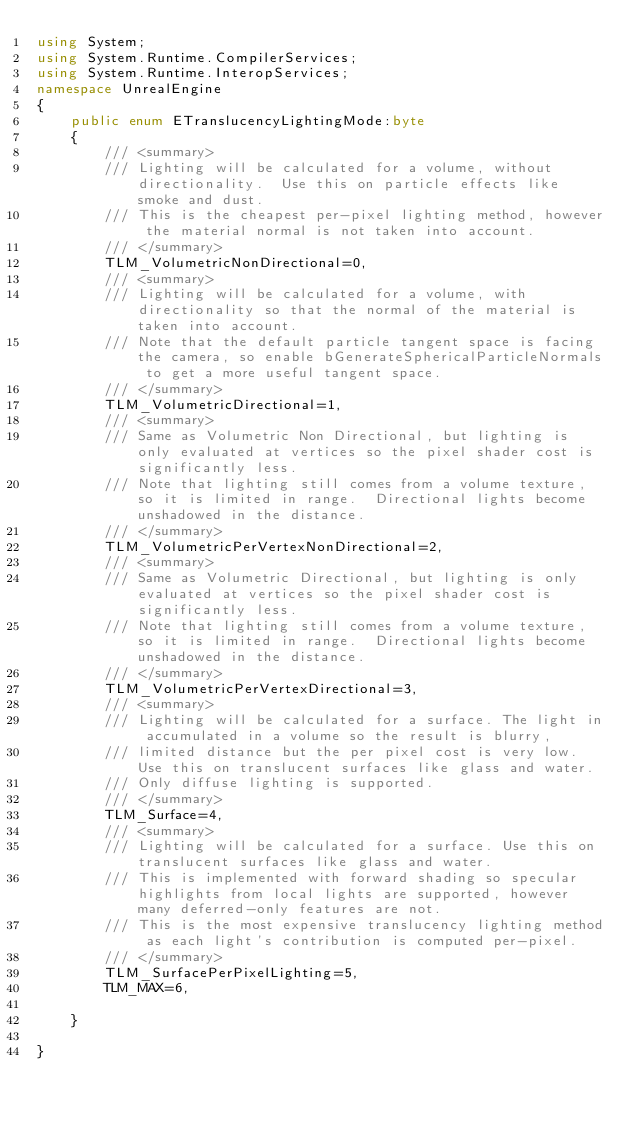<code> <loc_0><loc_0><loc_500><loc_500><_C#_>using System;
using System.Runtime.CompilerServices;
using System.Runtime.InteropServices;
namespace UnrealEngine
{
	public enum ETranslucencyLightingMode:byte
	{
		/// <summary>
		/// Lighting will be calculated for a volume, without directionality.  Use this on particle effects like smoke and dust.
		/// This is the cheapest per-pixel lighting method, however the material normal is not taken into account.
		/// </summary>
		TLM_VolumetricNonDirectional=0,
		/// <summary>
		/// Lighting will be calculated for a volume, with directionality so that the normal of the material is taken into account.
		/// Note that the default particle tangent space is facing the camera, so enable bGenerateSphericalParticleNormals to get a more useful tangent space.
		/// </summary>
		TLM_VolumetricDirectional=1,
		/// <summary>
		/// Same as Volumetric Non Directional, but lighting is only evaluated at vertices so the pixel shader cost is significantly less.
		/// Note that lighting still comes from a volume texture, so it is limited in range.  Directional lights become unshadowed in the distance.
		/// </summary>
		TLM_VolumetricPerVertexNonDirectional=2,
		/// <summary>
		/// Same as Volumetric Directional, but lighting is only evaluated at vertices so the pixel shader cost is significantly less.
		/// Note that lighting still comes from a volume texture, so it is limited in range.  Directional lights become unshadowed in the distance.
		/// </summary>
		TLM_VolumetricPerVertexDirectional=3,
		/// <summary>
		/// Lighting will be calculated for a surface. The light in accumulated in a volume so the result is blurry,
		/// limited distance but the per pixel cost is very low. Use this on translucent surfaces like glass and water.
		/// Only diffuse lighting is supported.
		/// </summary>
		TLM_Surface=4,
		/// <summary>
		/// Lighting will be calculated for a surface. Use this on translucent surfaces like glass and water.
		/// This is implemented with forward shading so specular highlights from local lights are supported, however many deferred-only features are not.
		/// This is the most expensive translucency lighting method as each light's contribution is computed per-pixel.
		/// </summary>
		TLM_SurfacePerPixelLighting=5,
		TLM_MAX=6,
		
	}
	
}
</code> 